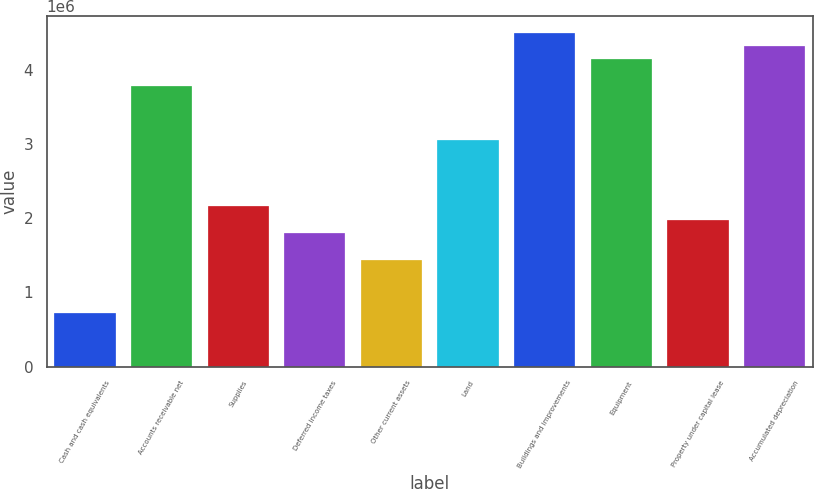Convert chart. <chart><loc_0><loc_0><loc_500><loc_500><bar_chart><fcel>Cash and cash equivalents<fcel>Accounts receivable net<fcel>Supplies<fcel>Deferred income taxes<fcel>Other current assets<fcel>Land<fcel>Buildings and improvements<fcel>Equipment<fcel>Property under capital lease<fcel>Accumulated depreciation<nl><fcel>719773<fcel>3.77879e+06<fcel>2.15931e+06<fcel>1.79943e+06<fcel>1.43954e+06<fcel>3.05902e+06<fcel>4.49856e+06<fcel>4.13868e+06<fcel>1.97937e+06<fcel>4.31862e+06<nl></chart> 